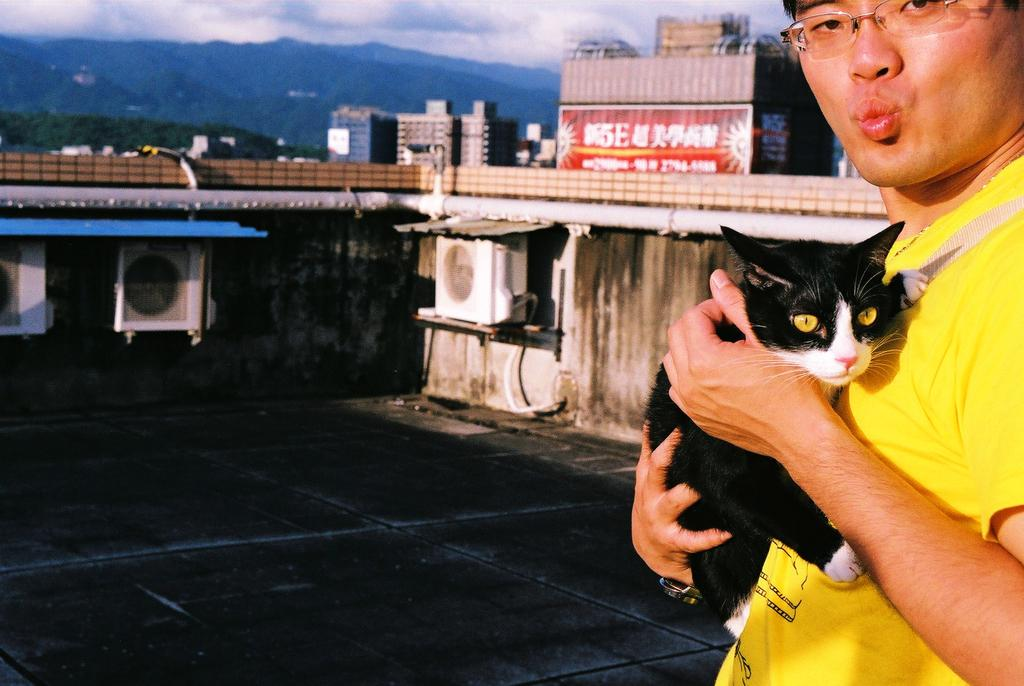What is the man doing on the left side of the image? The man is standing on the left side of the image and holding a cat in his hand. What can be seen in the background of the image? There is a wall, a building, and a mountain in the background of the image. What is the condition of the sky in the image? The sky is cloudy in the image. What type of letters is the committee discussing in the image? There is no committee or discussion of letters present in the image. How does the man feel about holding the cat in the image? The image does not provide information about the man's feelings or emotions. 